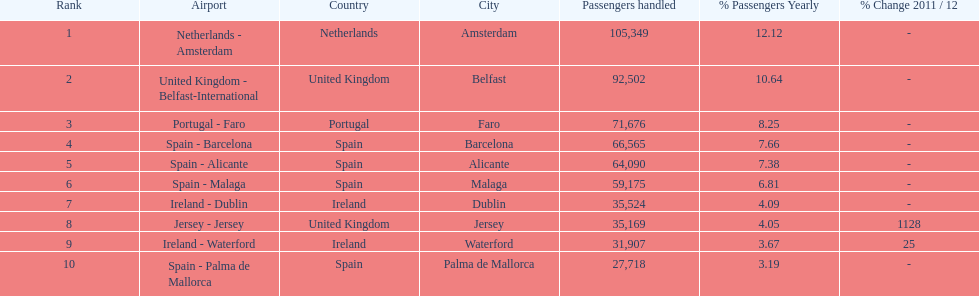Which airport had more passengers handled than the united kingdom? Netherlands - Amsterdam. Can you give me this table as a dict? {'header': ['Rank', 'Airport', 'Country', 'City', 'Passengers handled', '% Passengers Yearly', '% Change 2011 / 12'], 'rows': [['1', 'Netherlands - Amsterdam', 'Netherlands', 'Amsterdam', '105,349', '12.12', '-'], ['2', 'United Kingdom - Belfast-International', 'United Kingdom', 'Belfast', '92,502', '10.64', '-'], ['3', 'Portugal - Faro', 'Portugal', 'Faro', '71,676', '8.25', '-'], ['4', 'Spain - Barcelona', 'Spain', 'Barcelona', '66,565', '7.66', '-'], ['5', 'Spain - Alicante', 'Spain', 'Alicante', '64,090', '7.38', '-'], ['6', 'Spain - Malaga', 'Spain', 'Malaga', '59,175', '6.81', '-'], ['7', 'Ireland - Dublin', 'Ireland', 'Dublin', '35,524', '4.09', '-'], ['8', 'Jersey - Jersey', 'United Kingdom', 'Jersey', '35,169', '4.05', '1128'], ['9', 'Ireland - Waterford', 'Ireland', 'Waterford', '31,907', '3.67', '25'], ['10', 'Spain - Palma de Mallorca', 'Spain', 'Palma de Mallorca', '27,718', '3.19', '-']]} 